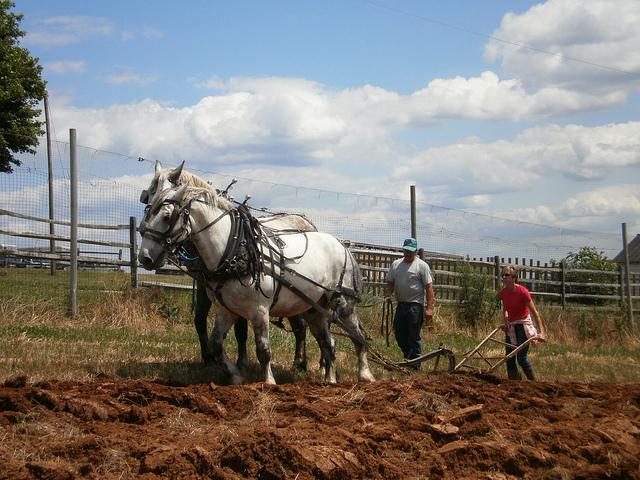Is this a modern farming method?
Short answer required. No. What tool do many people use other than this to till the ground?
Short answer required. Hoe. Is that a woman in the red shirt?
Concise answer only. No. 